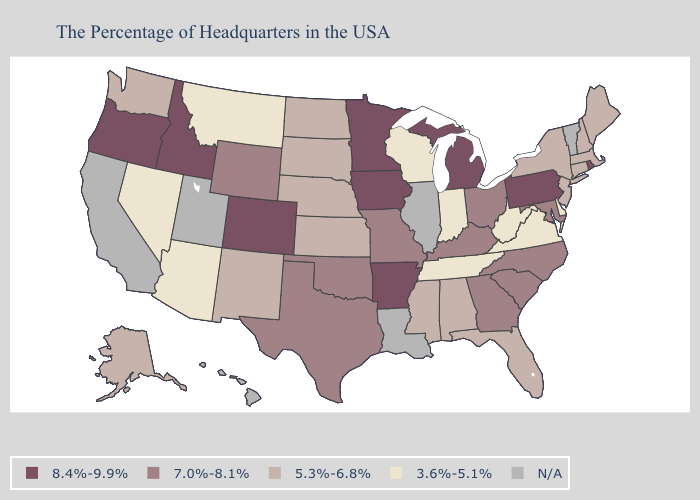What is the value of Mississippi?
Answer briefly. 5.3%-6.8%. What is the value of Nevada?
Quick response, please. 3.6%-5.1%. What is the highest value in states that border Nebraska?
Write a very short answer. 8.4%-9.9%. Which states have the highest value in the USA?
Give a very brief answer. Rhode Island, Pennsylvania, Michigan, Arkansas, Minnesota, Iowa, Colorado, Idaho, Oregon. What is the value of South Dakota?
Quick response, please. 5.3%-6.8%. What is the value of South Dakota?
Be succinct. 5.3%-6.8%. Among the states that border Ohio , which have the lowest value?
Answer briefly. West Virginia, Indiana. What is the highest value in the USA?
Concise answer only. 8.4%-9.9%. Does Nevada have the highest value in the USA?
Answer briefly. No. Among the states that border North Dakota , which have the highest value?
Concise answer only. Minnesota. 